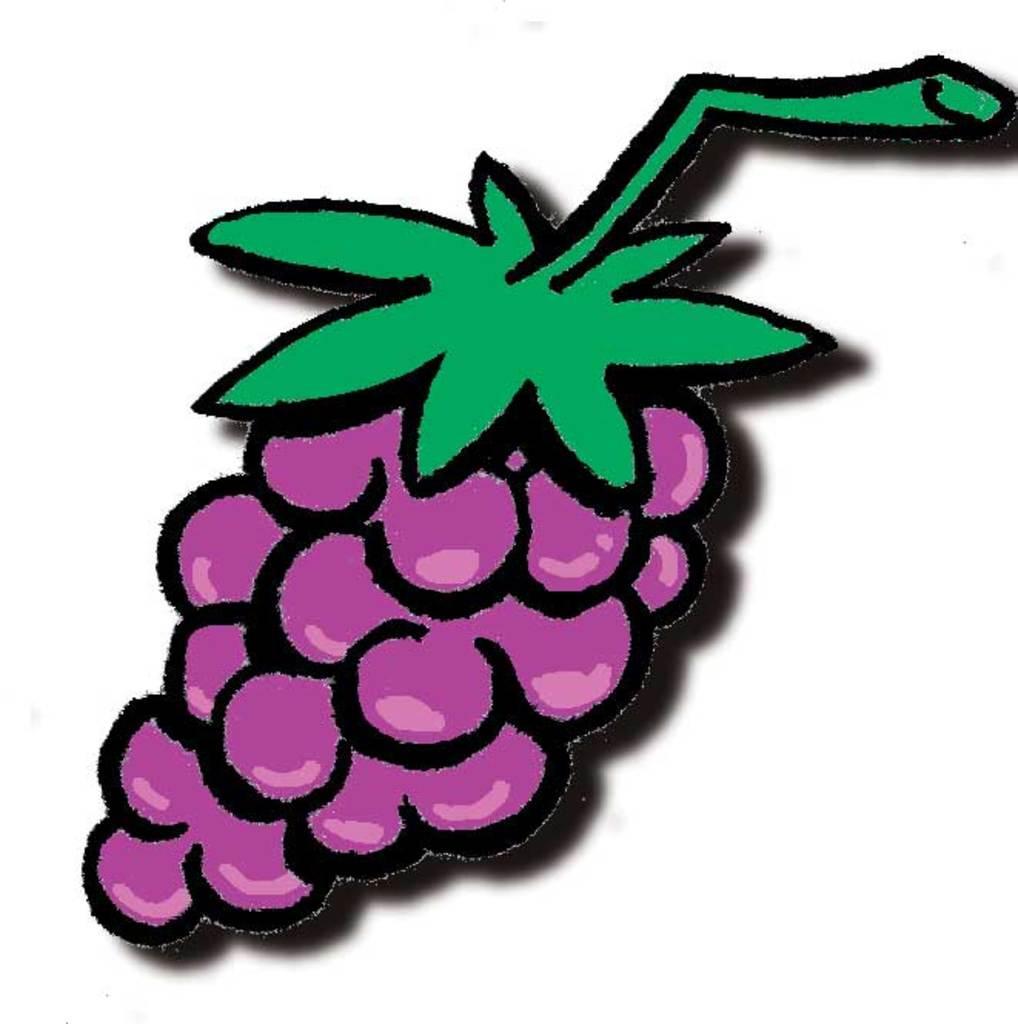Could you give a brief overview of what you see in this image? In this image we can see an art of grapes, which is in purple color and leaves in green color. The background of the image is white in color. 